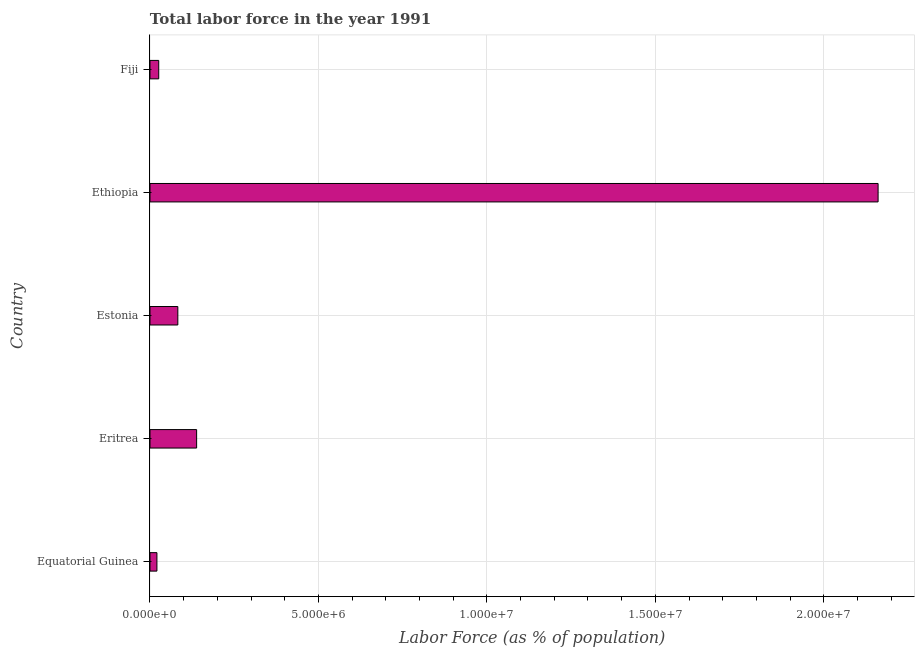What is the title of the graph?
Keep it short and to the point. Total labor force in the year 1991. What is the label or title of the X-axis?
Your answer should be compact. Labor Force (as % of population). What is the total labor force in Equatorial Guinea?
Offer a terse response. 2.06e+05. Across all countries, what is the maximum total labor force?
Your response must be concise. 2.16e+07. Across all countries, what is the minimum total labor force?
Your response must be concise. 2.06e+05. In which country was the total labor force maximum?
Make the answer very short. Ethiopia. In which country was the total labor force minimum?
Your answer should be very brief. Equatorial Guinea. What is the sum of the total labor force?
Provide a succinct answer. 2.43e+07. What is the difference between the total labor force in Equatorial Guinea and Eritrea?
Your answer should be compact. -1.18e+06. What is the average total labor force per country?
Offer a very short reply. 4.86e+06. What is the median total labor force?
Your answer should be compact. 8.26e+05. In how many countries, is the total labor force greater than 12000000 %?
Keep it short and to the point. 1. What is the ratio of the total labor force in Estonia to that in Ethiopia?
Your response must be concise. 0.04. Is the total labor force in Equatorial Guinea less than that in Fiji?
Provide a short and direct response. Yes. What is the difference between the highest and the second highest total labor force?
Ensure brevity in your answer.  2.02e+07. What is the difference between the highest and the lowest total labor force?
Give a very brief answer. 2.14e+07. In how many countries, is the total labor force greater than the average total labor force taken over all countries?
Your response must be concise. 1. How many bars are there?
Offer a very short reply. 5. How many countries are there in the graph?
Your answer should be compact. 5. What is the Labor Force (as % of population) in Equatorial Guinea?
Keep it short and to the point. 2.06e+05. What is the Labor Force (as % of population) in Eritrea?
Ensure brevity in your answer.  1.38e+06. What is the Labor Force (as % of population) in Estonia?
Your answer should be compact. 8.26e+05. What is the Labor Force (as % of population) in Ethiopia?
Your answer should be compact. 2.16e+07. What is the Labor Force (as % of population) of Fiji?
Ensure brevity in your answer.  2.59e+05. What is the difference between the Labor Force (as % of population) in Equatorial Guinea and Eritrea?
Your answer should be very brief. -1.18e+06. What is the difference between the Labor Force (as % of population) in Equatorial Guinea and Estonia?
Provide a short and direct response. -6.20e+05. What is the difference between the Labor Force (as % of population) in Equatorial Guinea and Ethiopia?
Your answer should be very brief. -2.14e+07. What is the difference between the Labor Force (as % of population) in Equatorial Guinea and Fiji?
Your answer should be very brief. -5.34e+04. What is the difference between the Labor Force (as % of population) in Eritrea and Estonia?
Offer a very short reply. 5.58e+05. What is the difference between the Labor Force (as % of population) in Eritrea and Ethiopia?
Your response must be concise. -2.02e+07. What is the difference between the Labor Force (as % of population) in Eritrea and Fiji?
Offer a very short reply. 1.12e+06. What is the difference between the Labor Force (as % of population) in Estonia and Ethiopia?
Your response must be concise. -2.08e+07. What is the difference between the Labor Force (as % of population) in Estonia and Fiji?
Keep it short and to the point. 5.67e+05. What is the difference between the Labor Force (as % of population) in Ethiopia and Fiji?
Your answer should be compact. 2.14e+07. What is the ratio of the Labor Force (as % of population) in Equatorial Guinea to that in Eritrea?
Provide a succinct answer. 0.15. What is the ratio of the Labor Force (as % of population) in Equatorial Guinea to that in Estonia?
Make the answer very short. 0.25. What is the ratio of the Labor Force (as % of population) in Equatorial Guinea to that in Fiji?
Your answer should be very brief. 0.79. What is the ratio of the Labor Force (as % of population) in Eritrea to that in Estonia?
Your response must be concise. 1.68. What is the ratio of the Labor Force (as % of population) in Eritrea to that in Ethiopia?
Provide a short and direct response. 0.06. What is the ratio of the Labor Force (as % of population) in Eritrea to that in Fiji?
Offer a terse response. 5.34. What is the ratio of the Labor Force (as % of population) in Estonia to that in Ethiopia?
Provide a succinct answer. 0.04. What is the ratio of the Labor Force (as % of population) in Estonia to that in Fiji?
Provide a short and direct response. 3.19. What is the ratio of the Labor Force (as % of population) in Ethiopia to that in Fiji?
Provide a succinct answer. 83.33. 